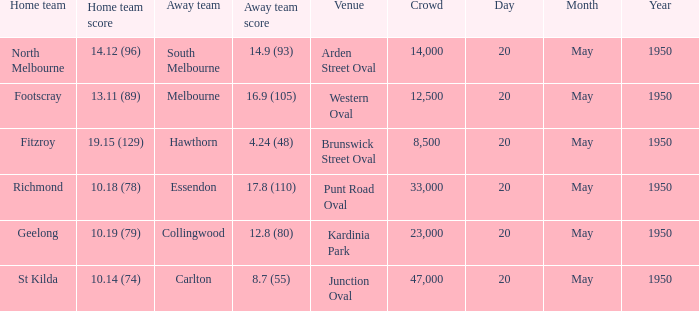What was the score for the away team that played against Richmond and has a crowd over 12,500? 17.8 (110). 